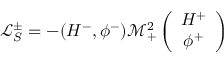<formula> <loc_0><loc_0><loc_500><loc_500>\mathcal { L } _ { S } ^ { \pm } = - ( H ^ { - } , \phi ^ { - } ) \mathcal { M } _ { + } ^ { 2 } \left ( \begin{array} { c } { { H ^ { + } } } \\ { { \phi ^ { + } } } \end{array} \right )</formula> 